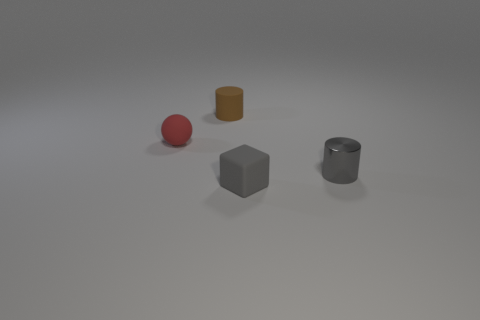Add 3 matte balls. How many objects exist? 7 Subtract all spheres. How many objects are left? 3 Add 1 matte things. How many matte things are left? 4 Add 4 small yellow cylinders. How many small yellow cylinders exist? 4 Subtract 0 brown blocks. How many objects are left? 4 Subtract all red matte objects. Subtract all tiny blocks. How many objects are left? 2 